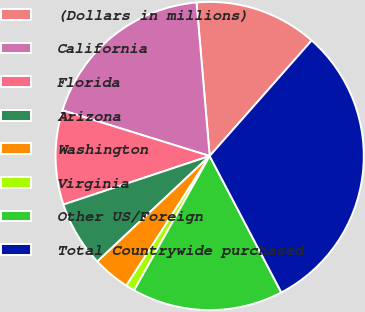Convert chart. <chart><loc_0><loc_0><loc_500><loc_500><pie_chart><fcel>(Dollars in millions)<fcel>California<fcel>Florida<fcel>Arizona<fcel>Washington<fcel>Virginia<fcel>Other US/Foreign<fcel>Total Countrywide purchased<nl><fcel>12.87%<fcel>18.85%<fcel>9.89%<fcel>6.9%<fcel>3.91%<fcel>0.93%<fcel>15.86%<fcel>30.79%<nl></chart> 